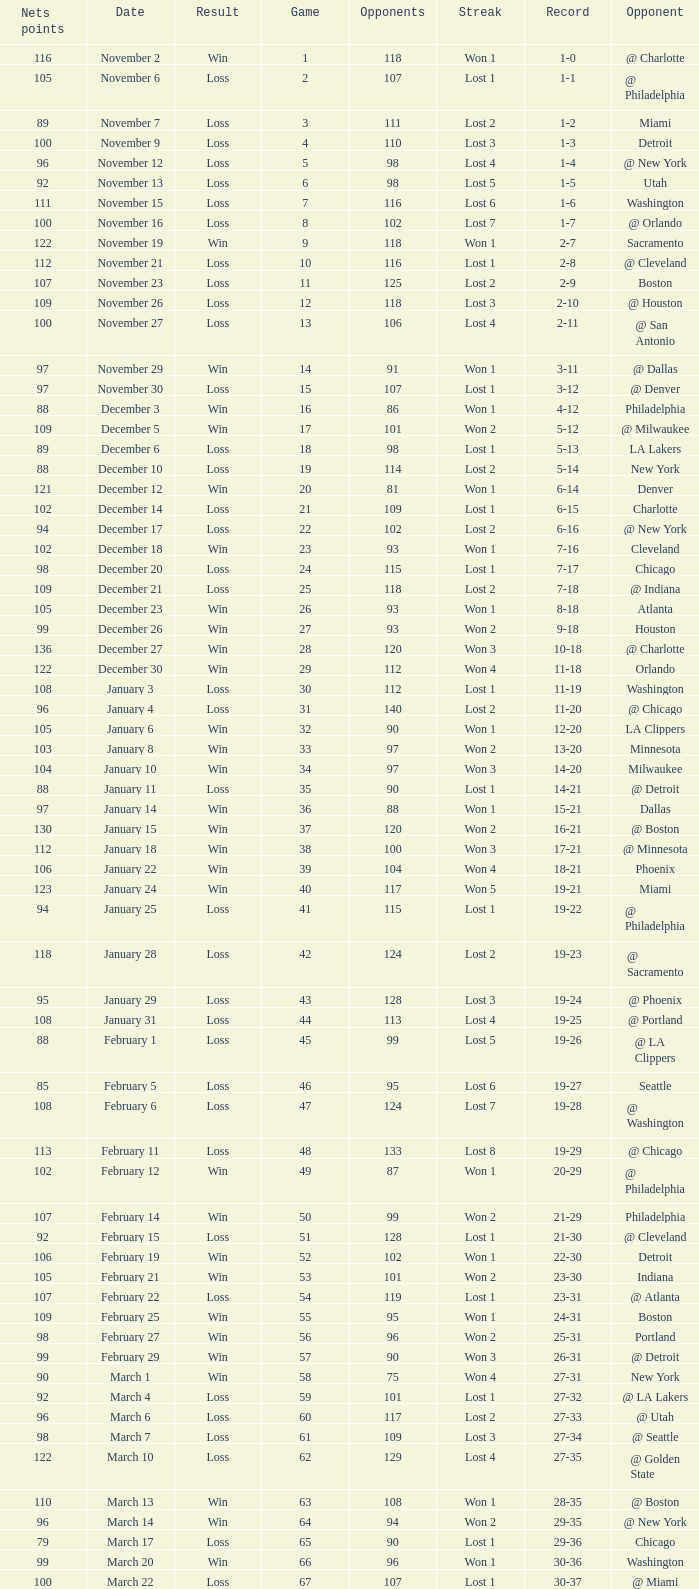How many games had fewer than 118 opponents and more than 109 net points with an opponent of Washington? 1.0. 